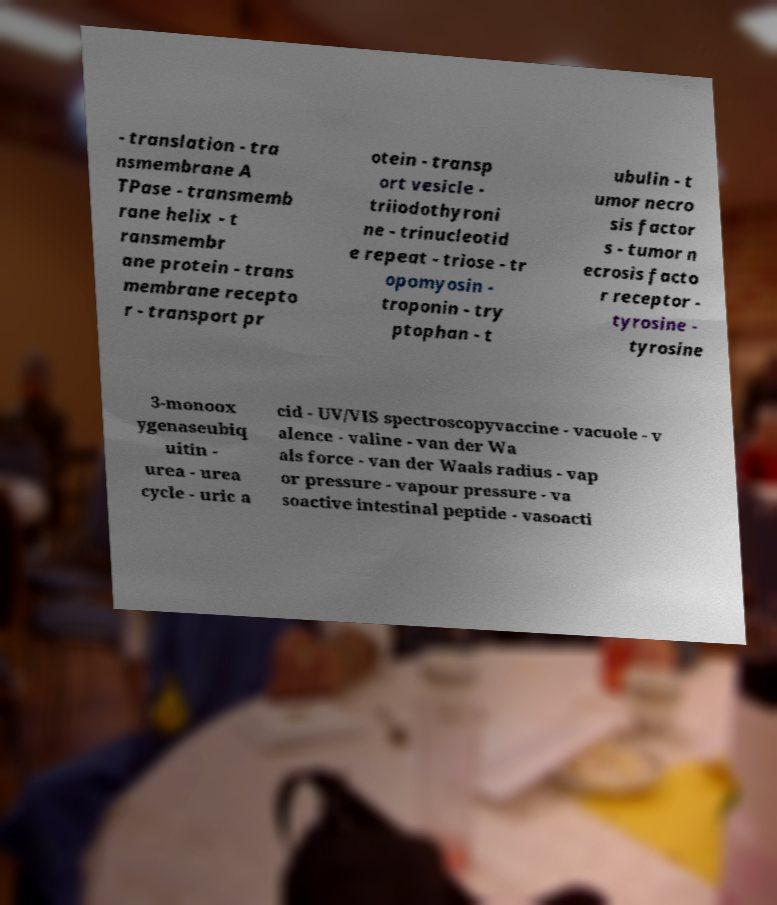Please read and relay the text visible in this image. What does it say? - translation - tra nsmembrane A TPase - transmemb rane helix - t ransmembr ane protein - trans membrane recepto r - transport pr otein - transp ort vesicle - triiodothyroni ne - trinucleotid e repeat - triose - tr opomyosin - troponin - try ptophan - t ubulin - t umor necro sis factor s - tumor n ecrosis facto r receptor - tyrosine - tyrosine 3-monoox ygenaseubiq uitin - urea - urea cycle - uric a cid - UV/VIS spectroscopyvaccine - vacuole - v alence - valine - van der Wa als force - van der Waals radius - vap or pressure - vapour pressure - va soactive intestinal peptide - vasoacti 